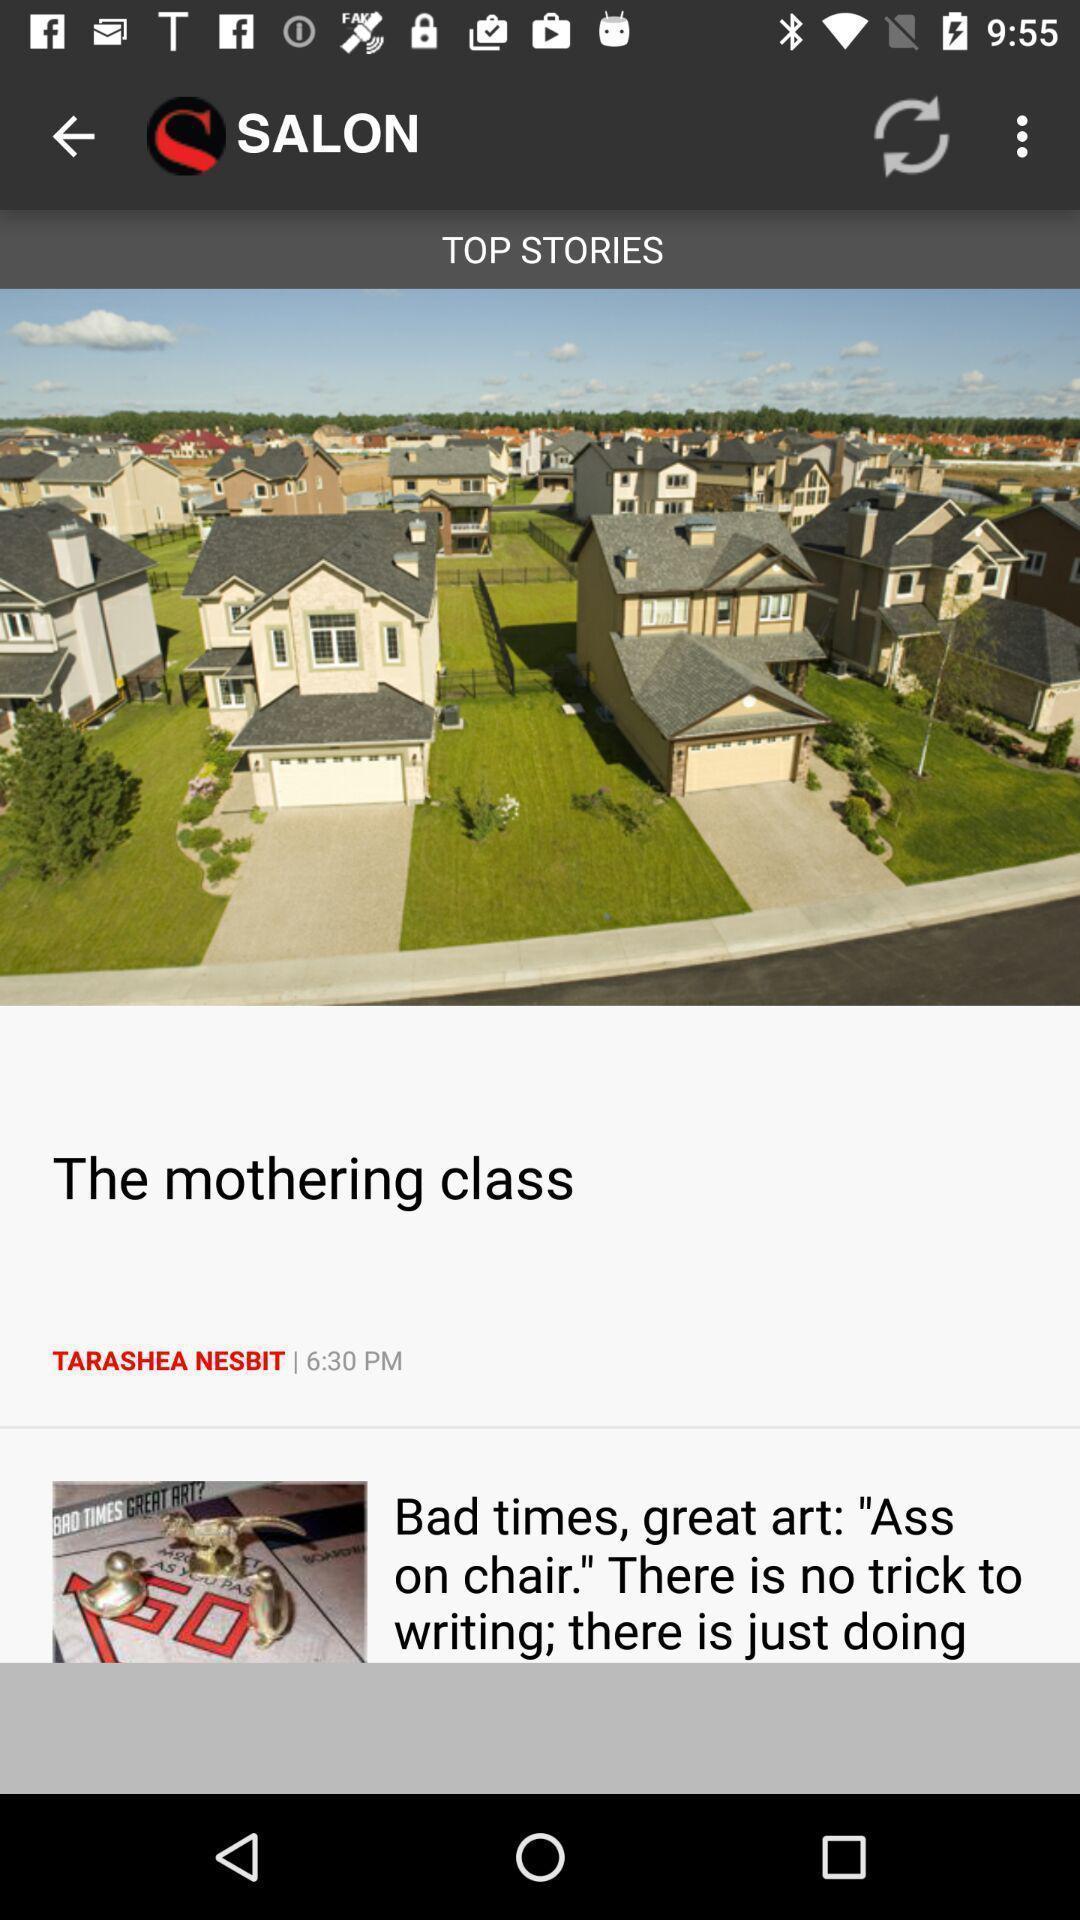Give me a summary of this screen capture. Top stories page of appointments in a marketing app. 